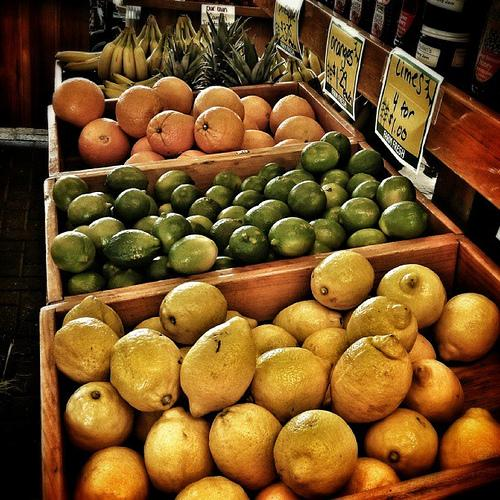Describe the signs associated with the different fruits in the image. There are multiple signs, such as a sign saying "limes 4 for a dollar", a sign advertising oranges for 129 each, and three signs promoting farm fresh fruit. Based on the information presented in the image, what kind of location is this, and what products are available for purchase? This appears to be a grocery store or produce market selling various fruits such as bananas, lemons, limes, oranges, and pineapples, and potentially jars of preserves as well. Identify the key elements in the image, including the types and quantity of fruit displayed. There are bananas, lemons, limes, oranges, and pineapples, with multiple instances of fruit located in wooden boxes, various signs advertising their price, and jars of preserves on a shelf. In the context of the image, explain the connection between the jars and the fruits. The jars of preserves on the shelf above the fruits suggest that the fruit is also used to create various fruit preserves, likely to be sold in the same store. What is unusual or surprising about one of the fruits in the image? There is a lemon with a black line in it, which is visually distinct and unusual compared to the other lemons. Mention the different fruits in the image and the signs promoting them. The image includes bananas, lemons, limes, oranges, and pineapples, with signs promoting limes 4 for a dollar, oranges for 129 each, and farm fresh fruit advertisements. Describe the emotional tone or atmosphere conveyed by the image, taking into account the visible elements and their arrangement. The image conveys a lively and abundant atmosphere with a variety of vibrant, fresh fruits, colorful and handwritten signs, and neatly organized wooden boxes. What is the meaning and purpose of the signs displayed in the image? The signs provide information about the prices and deals for the fruits, as well as promoting the freshness of the fruits available for sale. Can you find a cat hidden among the fruits? No, it's not mentioned in the image. How many signs are taped to the piece of wood? Three What's the subtitle written for the jar in the image? Jar with white lid Can you see a pineapple sliced in half in the image? The instruction is misleading because the information provided about pineapples does not mention any half-sliced pineapples. Which fruit has a black line in it? A lemon How many boxes of fruit are there in the photo? Four Are the bananas in the top-right corner of the image extremely small? The instruction is misleading because the bananas are described as having a width and height of 161, which suggests they are not small. Also, the position being mentioned (top-right corner) does not match with the given position (X:53 Y:25). Which of these signs has the correct text? a) limes for one dollar, b) limes four for one dollar, c) limes two for one dollar b) limes four for one dollar Is there any event happening in the image? No event What is the price for limes, as shown in the sign? 4 for a dollar In which type of container are the fruits stored? Wooden boxes Are the lemons in the bottom-left corner of the image blue? The instruction is misleading because lemons are typically yellow, not blue. What is the activity happening in this photo? Fruit for sale in a store Create a poem about the image. In a store where fruits reside, What is written on the yellow, black, and white handwritten sign? Oranges for 129 each Is the shelf above the fruit empty? No, there are jars of preserves on the shelf Do the boxes of oranges have any accompanying signs? Yes, a sign advertising oranges for 129 each Describe the setting of the image. Fruit for sale in a store with wooden boxes and multiple signs Provide a brief description of the scene in the picture. Fruit for sale in a store, with various types in wooden boxes, and signs indicating their prices How many different kinds of fruit are there in picture? Five List all types of fruits in the picture. bananas, lemons, limes, oranges, pineapples Identify the object with the yellow and black sign. Limes Which fruit is in the top left corner of the image? Bananas 